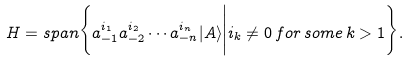Convert formula to latex. <formula><loc_0><loc_0><loc_500><loc_500>H = s p a n \Big \{ a _ { - 1 } ^ { i _ { 1 } } a _ { - 2 } ^ { i _ { 2 } } \cdots a _ { - n } ^ { i _ { n } } | A \rangle \Big | i _ { k } \neq 0 \, f o r \, s o m e \, k > 1 \Big \} .</formula> 